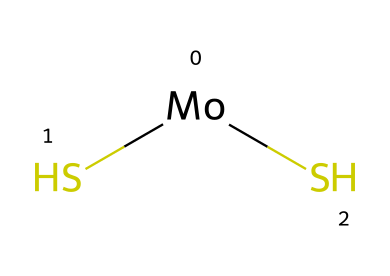What is the molecular formula of this compound? The molecular formula can be determined by counting the different types of atoms in the SMILES representation. There is one molybdenum (Mo) atom and two sulfur (S) atoms. This leads to the formula MoS2.
Answer: MoS2 How many sulfur atoms are present in the compound? By examining the SMILES representation, we can see the "(S)(S)" indicating two sulfur atoms are bonded to the molybdenum atom.
Answer: 2 What type of material is molybdenum disulfide commonly used as? Molybdenum disulfide is recognized for its properties as a solid lubricant, primarily because of its layered structure that allows for easy sliding between layers.
Answer: lubricant What is the coordination number of molybdenum in this structure? Molybdenum is bonded to two sulfur atoms in this compound, giving it a coordination number of two, which refers to the number of atoms directly bonded to it.
Answer: 2 Why is molybdenum disulfide effective as a lubricant at high temperatures? Due to its strong covalent bonds within each layer and weak van der Waals forces between layers, molybdenum disulfide maintains stability and effectiveness as a lubricant even at elevated temperatures.
Answer: stability What characteristic structural feature of molybdenum disulfide facilitates its lubrication properties? The layered structure of molybdenum disulfide allows the layers to slide over each other easily, reducing friction and wear in mechanical systems.
Answer: layered structure 